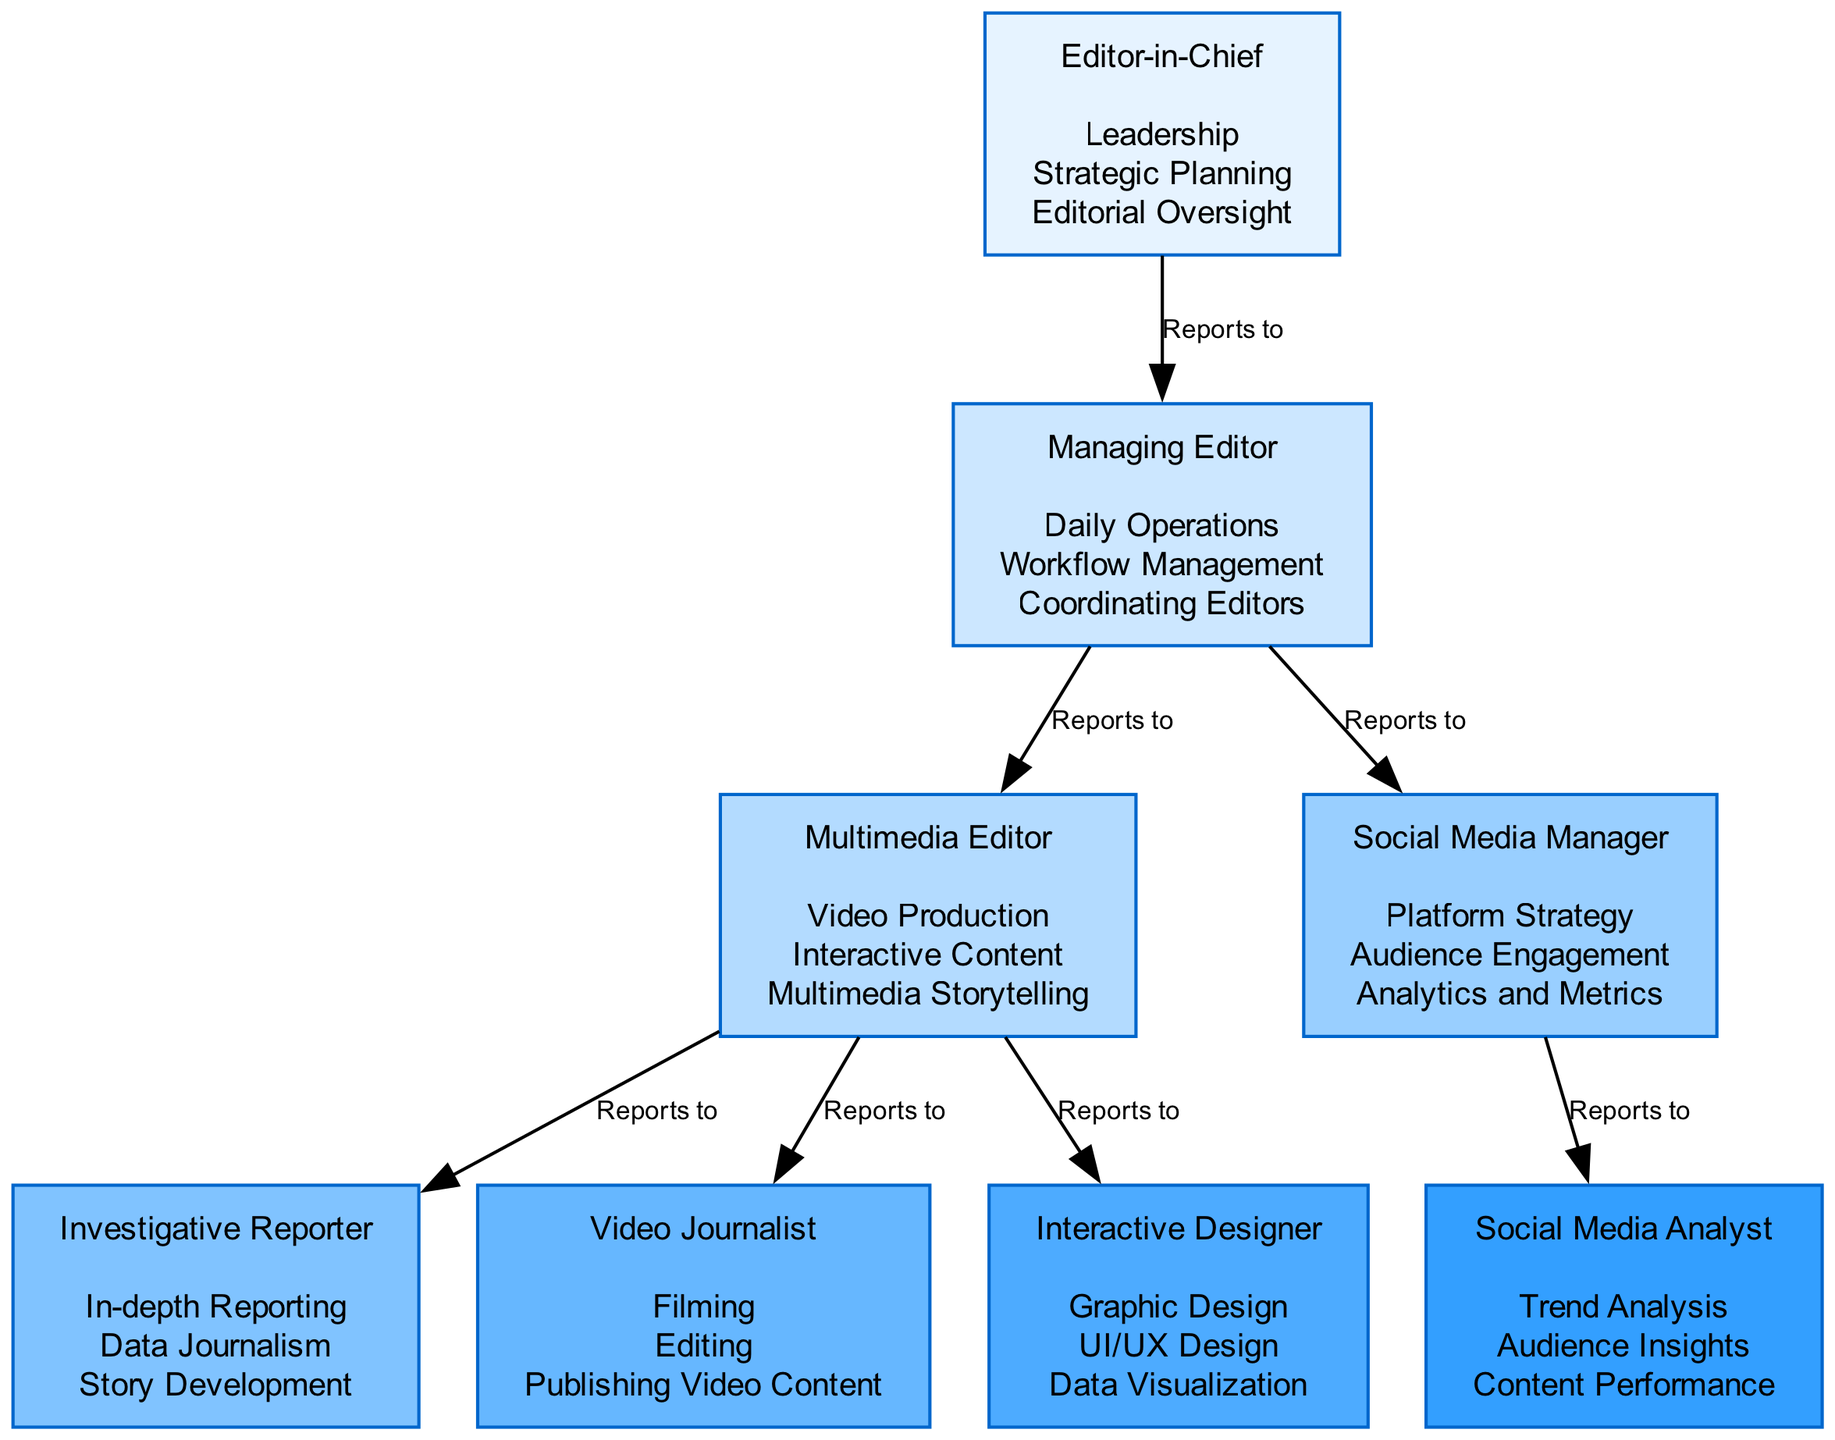What is the top position in the hierarchy? The diagram identifies the "Editor-in-Chief" as the highest role, which does not report to anyone else. This can be determined easily since this node has no incoming edges from other nodes.
Answer: Editor-in-Chief How many total roles are depicted in the diagram? By counting all individual blocks in the diagram, we find there are eight distinct roles, shown as separate nodes, making it a simple count of nodes present.
Answer: 8 Who does the Multimedia Editor report to? Looking at the connections, the "Multimedia Editor" is directly connected with the "Managing Editor," indicating this hierarchy. This relationship is depicted through an edge labeled "Reports to."
Answer: Managing Editor What are the responsibilities of the Social Media Manager? By examining the box labeled "Social Media Manager," we see it outlines three specific responsibilities listed below the title, revealing what is expected of that role.
Answer: Platform Strategy, Audience Engagement, Analytics and Metrics What roles directly report to the Managing Editor? The roles connected to the "Managing Editor" include the "Multimedia Editor" and the "Social Media Manager," as indicated by the outgoing edges from the Managing Editor node toward these other roles.
Answer: Multimedia Editor, Social Media Manager Which role has the responsibility of "Data Visualization"? In the diagram, the "Interactive Designer" is the role that lists "Data Visualization" among its responsibilities, making it clear that this specific task falls under this position.
Answer: Interactive Designer How many roles report to the Social Media Manager? Upon close inspection, the "Social Media Manager" does not have any roles reporting to it, as there are no outgoing edges from that node in the diagram.
Answer: 0 Which role has two reporting roles and what are they? The "Multimedia Editor" is connected to two roles: "Investigative Reporter" and "Video Journalist," indicated by two edges that flow out from the Multimedia Editor to these respective nodes.
Answer: Investigative Reporter, Video Journalist What responsibilities does the Video Journalist handle? The responsibilities are specified under the "Video Journalist" node in the diagram and include filming, editing, and publishing video content, illustrating the role's core functions.
Answer: Filming, Editing, Publishing Video Content 